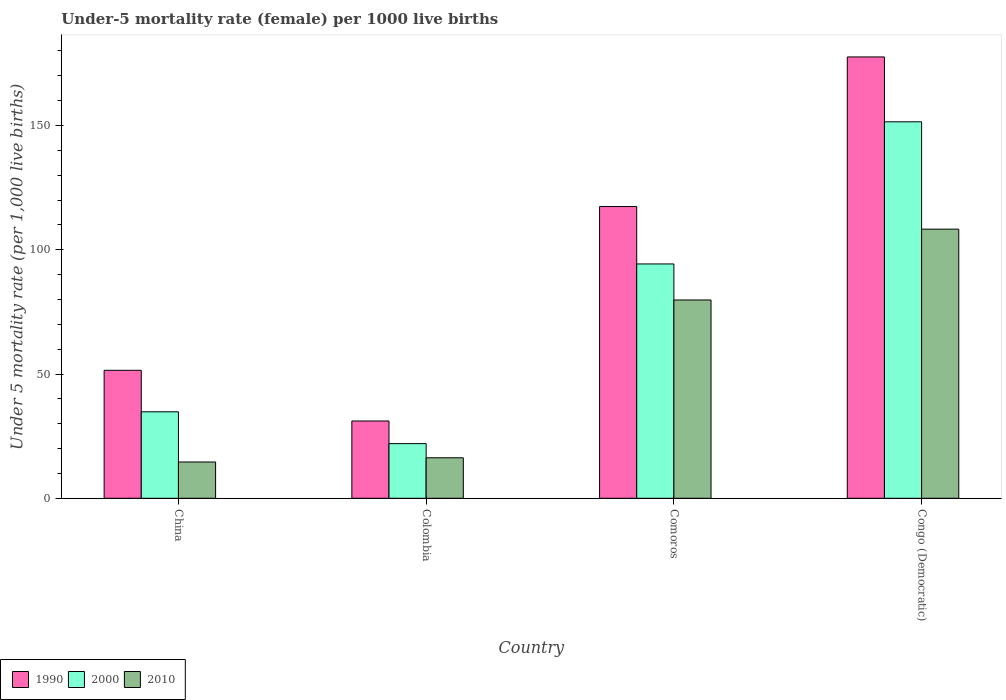How many different coloured bars are there?
Keep it short and to the point. 3. Are the number of bars per tick equal to the number of legend labels?
Make the answer very short. Yes. How many bars are there on the 2nd tick from the right?
Ensure brevity in your answer.  3. What is the label of the 1st group of bars from the left?
Offer a very short reply. China. In how many cases, is the number of bars for a given country not equal to the number of legend labels?
Offer a terse response. 0. What is the under-five mortality rate in 1990 in Comoros?
Provide a short and direct response. 117.4. Across all countries, what is the maximum under-five mortality rate in 1990?
Your response must be concise. 177.6. Across all countries, what is the minimum under-five mortality rate in 2000?
Your answer should be compact. 22. In which country was the under-five mortality rate in 2010 maximum?
Give a very brief answer. Congo (Democratic). What is the total under-five mortality rate in 2000 in the graph?
Give a very brief answer. 302.6. What is the difference between the under-five mortality rate in 2000 in China and that in Congo (Democratic)?
Give a very brief answer. -116.7. What is the difference between the under-five mortality rate in 2010 in Comoros and the under-five mortality rate in 2000 in Congo (Democratic)?
Give a very brief answer. -71.7. What is the average under-five mortality rate in 2000 per country?
Make the answer very short. 75.65. What is the difference between the under-five mortality rate of/in 1990 and under-five mortality rate of/in 2000 in China?
Your response must be concise. 16.7. What is the ratio of the under-five mortality rate in 2010 in China to that in Congo (Democratic)?
Your response must be concise. 0.13. Is the under-five mortality rate in 2010 in Comoros less than that in Congo (Democratic)?
Give a very brief answer. Yes. What is the difference between the highest and the second highest under-five mortality rate in 2000?
Offer a very short reply. -59.5. What is the difference between the highest and the lowest under-five mortality rate in 2010?
Offer a very short reply. 93.7. Is the sum of the under-five mortality rate in 2010 in China and Congo (Democratic) greater than the maximum under-five mortality rate in 2000 across all countries?
Your response must be concise. No. What does the 1st bar from the left in China represents?
Your answer should be very brief. 1990. How many bars are there?
Keep it short and to the point. 12. Are all the bars in the graph horizontal?
Provide a short and direct response. No. What is the difference between two consecutive major ticks on the Y-axis?
Keep it short and to the point. 50. Are the values on the major ticks of Y-axis written in scientific E-notation?
Make the answer very short. No. Does the graph contain grids?
Make the answer very short. No. Where does the legend appear in the graph?
Provide a short and direct response. Bottom left. How many legend labels are there?
Provide a short and direct response. 3. How are the legend labels stacked?
Provide a succinct answer. Horizontal. What is the title of the graph?
Make the answer very short. Under-5 mortality rate (female) per 1000 live births. What is the label or title of the Y-axis?
Your answer should be compact. Under 5 mortality rate (per 1,0 live births). What is the Under 5 mortality rate (per 1,000 live births) in 1990 in China?
Your answer should be very brief. 51.5. What is the Under 5 mortality rate (per 1,000 live births) of 2000 in China?
Provide a succinct answer. 34.8. What is the Under 5 mortality rate (per 1,000 live births) of 1990 in Colombia?
Your response must be concise. 31.1. What is the Under 5 mortality rate (per 1,000 live births) of 2000 in Colombia?
Your answer should be very brief. 22. What is the Under 5 mortality rate (per 1,000 live births) in 1990 in Comoros?
Provide a short and direct response. 117.4. What is the Under 5 mortality rate (per 1,000 live births) of 2000 in Comoros?
Your answer should be very brief. 94.3. What is the Under 5 mortality rate (per 1,000 live births) of 2010 in Comoros?
Ensure brevity in your answer.  79.8. What is the Under 5 mortality rate (per 1,000 live births) of 1990 in Congo (Democratic)?
Ensure brevity in your answer.  177.6. What is the Under 5 mortality rate (per 1,000 live births) of 2000 in Congo (Democratic)?
Ensure brevity in your answer.  151.5. What is the Under 5 mortality rate (per 1,000 live births) of 2010 in Congo (Democratic)?
Give a very brief answer. 108.3. Across all countries, what is the maximum Under 5 mortality rate (per 1,000 live births) in 1990?
Your answer should be very brief. 177.6. Across all countries, what is the maximum Under 5 mortality rate (per 1,000 live births) in 2000?
Make the answer very short. 151.5. Across all countries, what is the maximum Under 5 mortality rate (per 1,000 live births) of 2010?
Provide a succinct answer. 108.3. Across all countries, what is the minimum Under 5 mortality rate (per 1,000 live births) of 1990?
Provide a short and direct response. 31.1. Across all countries, what is the minimum Under 5 mortality rate (per 1,000 live births) of 2000?
Offer a very short reply. 22. What is the total Under 5 mortality rate (per 1,000 live births) in 1990 in the graph?
Keep it short and to the point. 377.6. What is the total Under 5 mortality rate (per 1,000 live births) in 2000 in the graph?
Your answer should be compact. 302.6. What is the total Under 5 mortality rate (per 1,000 live births) in 2010 in the graph?
Make the answer very short. 219. What is the difference between the Under 5 mortality rate (per 1,000 live births) of 1990 in China and that in Colombia?
Provide a succinct answer. 20.4. What is the difference between the Under 5 mortality rate (per 1,000 live births) in 2000 in China and that in Colombia?
Offer a terse response. 12.8. What is the difference between the Under 5 mortality rate (per 1,000 live births) of 1990 in China and that in Comoros?
Keep it short and to the point. -65.9. What is the difference between the Under 5 mortality rate (per 1,000 live births) in 2000 in China and that in Comoros?
Make the answer very short. -59.5. What is the difference between the Under 5 mortality rate (per 1,000 live births) in 2010 in China and that in Comoros?
Provide a succinct answer. -65.2. What is the difference between the Under 5 mortality rate (per 1,000 live births) of 1990 in China and that in Congo (Democratic)?
Offer a very short reply. -126.1. What is the difference between the Under 5 mortality rate (per 1,000 live births) in 2000 in China and that in Congo (Democratic)?
Give a very brief answer. -116.7. What is the difference between the Under 5 mortality rate (per 1,000 live births) in 2010 in China and that in Congo (Democratic)?
Provide a succinct answer. -93.7. What is the difference between the Under 5 mortality rate (per 1,000 live births) of 1990 in Colombia and that in Comoros?
Offer a very short reply. -86.3. What is the difference between the Under 5 mortality rate (per 1,000 live births) in 2000 in Colombia and that in Comoros?
Offer a terse response. -72.3. What is the difference between the Under 5 mortality rate (per 1,000 live births) in 2010 in Colombia and that in Comoros?
Give a very brief answer. -63.5. What is the difference between the Under 5 mortality rate (per 1,000 live births) of 1990 in Colombia and that in Congo (Democratic)?
Keep it short and to the point. -146.5. What is the difference between the Under 5 mortality rate (per 1,000 live births) of 2000 in Colombia and that in Congo (Democratic)?
Give a very brief answer. -129.5. What is the difference between the Under 5 mortality rate (per 1,000 live births) of 2010 in Colombia and that in Congo (Democratic)?
Provide a succinct answer. -92. What is the difference between the Under 5 mortality rate (per 1,000 live births) in 1990 in Comoros and that in Congo (Democratic)?
Your answer should be compact. -60.2. What is the difference between the Under 5 mortality rate (per 1,000 live births) in 2000 in Comoros and that in Congo (Democratic)?
Keep it short and to the point. -57.2. What is the difference between the Under 5 mortality rate (per 1,000 live births) in 2010 in Comoros and that in Congo (Democratic)?
Your answer should be very brief. -28.5. What is the difference between the Under 5 mortality rate (per 1,000 live births) in 1990 in China and the Under 5 mortality rate (per 1,000 live births) in 2000 in Colombia?
Offer a very short reply. 29.5. What is the difference between the Under 5 mortality rate (per 1,000 live births) in 1990 in China and the Under 5 mortality rate (per 1,000 live births) in 2010 in Colombia?
Your answer should be compact. 35.2. What is the difference between the Under 5 mortality rate (per 1,000 live births) in 1990 in China and the Under 5 mortality rate (per 1,000 live births) in 2000 in Comoros?
Provide a succinct answer. -42.8. What is the difference between the Under 5 mortality rate (per 1,000 live births) of 1990 in China and the Under 5 mortality rate (per 1,000 live births) of 2010 in Comoros?
Offer a very short reply. -28.3. What is the difference between the Under 5 mortality rate (per 1,000 live births) in 2000 in China and the Under 5 mortality rate (per 1,000 live births) in 2010 in Comoros?
Provide a short and direct response. -45. What is the difference between the Under 5 mortality rate (per 1,000 live births) in 1990 in China and the Under 5 mortality rate (per 1,000 live births) in 2000 in Congo (Democratic)?
Make the answer very short. -100. What is the difference between the Under 5 mortality rate (per 1,000 live births) of 1990 in China and the Under 5 mortality rate (per 1,000 live births) of 2010 in Congo (Democratic)?
Provide a short and direct response. -56.8. What is the difference between the Under 5 mortality rate (per 1,000 live births) in 2000 in China and the Under 5 mortality rate (per 1,000 live births) in 2010 in Congo (Democratic)?
Your answer should be very brief. -73.5. What is the difference between the Under 5 mortality rate (per 1,000 live births) of 1990 in Colombia and the Under 5 mortality rate (per 1,000 live births) of 2000 in Comoros?
Keep it short and to the point. -63.2. What is the difference between the Under 5 mortality rate (per 1,000 live births) in 1990 in Colombia and the Under 5 mortality rate (per 1,000 live births) in 2010 in Comoros?
Your answer should be very brief. -48.7. What is the difference between the Under 5 mortality rate (per 1,000 live births) of 2000 in Colombia and the Under 5 mortality rate (per 1,000 live births) of 2010 in Comoros?
Your answer should be very brief. -57.8. What is the difference between the Under 5 mortality rate (per 1,000 live births) in 1990 in Colombia and the Under 5 mortality rate (per 1,000 live births) in 2000 in Congo (Democratic)?
Your answer should be very brief. -120.4. What is the difference between the Under 5 mortality rate (per 1,000 live births) in 1990 in Colombia and the Under 5 mortality rate (per 1,000 live births) in 2010 in Congo (Democratic)?
Provide a short and direct response. -77.2. What is the difference between the Under 5 mortality rate (per 1,000 live births) in 2000 in Colombia and the Under 5 mortality rate (per 1,000 live births) in 2010 in Congo (Democratic)?
Your answer should be very brief. -86.3. What is the difference between the Under 5 mortality rate (per 1,000 live births) of 1990 in Comoros and the Under 5 mortality rate (per 1,000 live births) of 2000 in Congo (Democratic)?
Ensure brevity in your answer.  -34.1. What is the difference between the Under 5 mortality rate (per 1,000 live births) in 1990 in Comoros and the Under 5 mortality rate (per 1,000 live births) in 2010 in Congo (Democratic)?
Your response must be concise. 9.1. What is the difference between the Under 5 mortality rate (per 1,000 live births) in 2000 in Comoros and the Under 5 mortality rate (per 1,000 live births) in 2010 in Congo (Democratic)?
Offer a very short reply. -14. What is the average Under 5 mortality rate (per 1,000 live births) of 1990 per country?
Offer a terse response. 94.4. What is the average Under 5 mortality rate (per 1,000 live births) of 2000 per country?
Your answer should be very brief. 75.65. What is the average Under 5 mortality rate (per 1,000 live births) of 2010 per country?
Provide a short and direct response. 54.75. What is the difference between the Under 5 mortality rate (per 1,000 live births) in 1990 and Under 5 mortality rate (per 1,000 live births) in 2000 in China?
Give a very brief answer. 16.7. What is the difference between the Under 5 mortality rate (per 1,000 live births) of 1990 and Under 5 mortality rate (per 1,000 live births) of 2010 in China?
Offer a very short reply. 36.9. What is the difference between the Under 5 mortality rate (per 1,000 live births) in 2000 and Under 5 mortality rate (per 1,000 live births) in 2010 in China?
Offer a very short reply. 20.2. What is the difference between the Under 5 mortality rate (per 1,000 live births) in 1990 and Under 5 mortality rate (per 1,000 live births) in 2000 in Colombia?
Offer a terse response. 9.1. What is the difference between the Under 5 mortality rate (per 1,000 live births) of 1990 and Under 5 mortality rate (per 1,000 live births) of 2000 in Comoros?
Your answer should be compact. 23.1. What is the difference between the Under 5 mortality rate (per 1,000 live births) in 1990 and Under 5 mortality rate (per 1,000 live births) in 2010 in Comoros?
Keep it short and to the point. 37.6. What is the difference between the Under 5 mortality rate (per 1,000 live births) of 2000 and Under 5 mortality rate (per 1,000 live births) of 2010 in Comoros?
Your answer should be very brief. 14.5. What is the difference between the Under 5 mortality rate (per 1,000 live births) in 1990 and Under 5 mortality rate (per 1,000 live births) in 2000 in Congo (Democratic)?
Give a very brief answer. 26.1. What is the difference between the Under 5 mortality rate (per 1,000 live births) of 1990 and Under 5 mortality rate (per 1,000 live births) of 2010 in Congo (Democratic)?
Provide a succinct answer. 69.3. What is the difference between the Under 5 mortality rate (per 1,000 live births) of 2000 and Under 5 mortality rate (per 1,000 live births) of 2010 in Congo (Democratic)?
Offer a very short reply. 43.2. What is the ratio of the Under 5 mortality rate (per 1,000 live births) of 1990 in China to that in Colombia?
Provide a short and direct response. 1.66. What is the ratio of the Under 5 mortality rate (per 1,000 live births) of 2000 in China to that in Colombia?
Keep it short and to the point. 1.58. What is the ratio of the Under 5 mortality rate (per 1,000 live births) in 2010 in China to that in Colombia?
Give a very brief answer. 0.9. What is the ratio of the Under 5 mortality rate (per 1,000 live births) of 1990 in China to that in Comoros?
Offer a terse response. 0.44. What is the ratio of the Under 5 mortality rate (per 1,000 live births) of 2000 in China to that in Comoros?
Your answer should be very brief. 0.37. What is the ratio of the Under 5 mortality rate (per 1,000 live births) of 2010 in China to that in Comoros?
Ensure brevity in your answer.  0.18. What is the ratio of the Under 5 mortality rate (per 1,000 live births) in 1990 in China to that in Congo (Democratic)?
Offer a very short reply. 0.29. What is the ratio of the Under 5 mortality rate (per 1,000 live births) of 2000 in China to that in Congo (Democratic)?
Your response must be concise. 0.23. What is the ratio of the Under 5 mortality rate (per 1,000 live births) in 2010 in China to that in Congo (Democratic)?
Offer a very short reply. 0.13. What is the ratio of the Under 5 mortality rate (per 1,000 live births) of 1990 in Colombia to that in Comoros?
Your response must be concise. 0.26. What is the ratio of the Under 5 mortality rate (per 1,000 live births) in 2000 in Colombia to that in Comoros?
Offer a terse response. 0.23. What is the ratio of the Under 5 mortality rate (per 1,000 live births) of 2010 in Colombia to that in Comoros?
Ensure brevity in your answer.  0.2. What is the ratio of the Under 5 mortality rate (per 1,000 live births) of 1990 in Colombia to that in Congo (Democratic)?
Your answer should be compact. 0.18. What is the ratio of the Under 5 mortality rate (per 1,000 live births) of 2000 in Colombia to that in Congo (Democratic)?
Provide a short and direct response. 0.15. What is the ratio of the Under 5 mortality rate (per 1,000 live births) of 2010 in Colombia to that in Congo (Democratic)?
Offer a very short reply. 0.15. What is the ratio of the Under 5 mortality rate (per 1,000 live births) of 1990 in Comoros to that in Congo (Democratic)?
Ensure brevity in your answer.  0.66. What is the ratio of the Under 5 mortality rate (per 1,000 live births) in 2000 in Comoros to that in Congo (Democratic)?
Give a very brief answer. 0.62. What is the ratio of the Under 5 mortality rate (per 1,000 live births) in 2010 in Comoros to that in Congo (Democratic)?
Your response must be concise. 0.74. What is the difference between the highest and the second highest Under 5 mortality rate (per 1,000 live births) of 1990?
Your answer should be compact. 60.2. What is the difference between the highest and the second highest Under 5 mortality rate (per 1,000 live births) of 2000?
Your answer should be compact. 57.2. What is the difference between the highest and the lowest Under 5 mortality rate (per 1,000 live births) of 1990?
Your answer should be compact. 146.5. What is the difference between the highest and the lowest Under 5 mortality rate (per 1,000 live births) of 2000?
Your response must be concise. 129.5. What is the difference between the highest and the lowest Under 5 mortality rate (per 1,000 live births) in 2010?
Give a very brief answer. 93.7. 